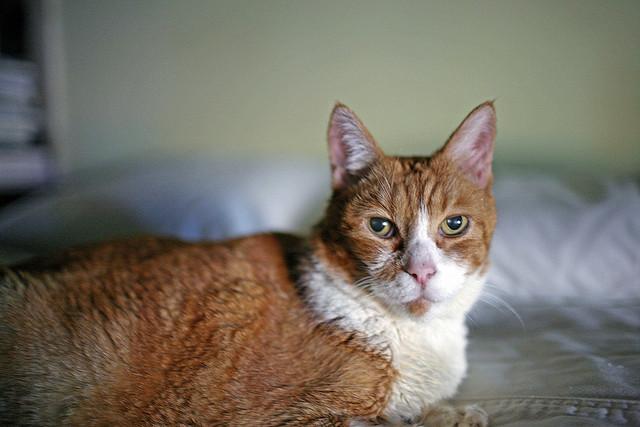What color are the inside of the cat's ears?
Quick response, please. Pink. Is the pet in its bed?
Write a very short answer. No. What is the cat sitting next to?
Short answer required. Pillow. What color is the cat?
Quick response, please. Orange and white. What is the kitty laying on?
Answer briefly. Bed. Is this the cats bed?
Be succinct. No. Where do you think this picture is taken?
Short answer required. Bedroom. Is the cat outdoors?
Be succinct. No. What animal is this?
Quick response, please. Cat. 